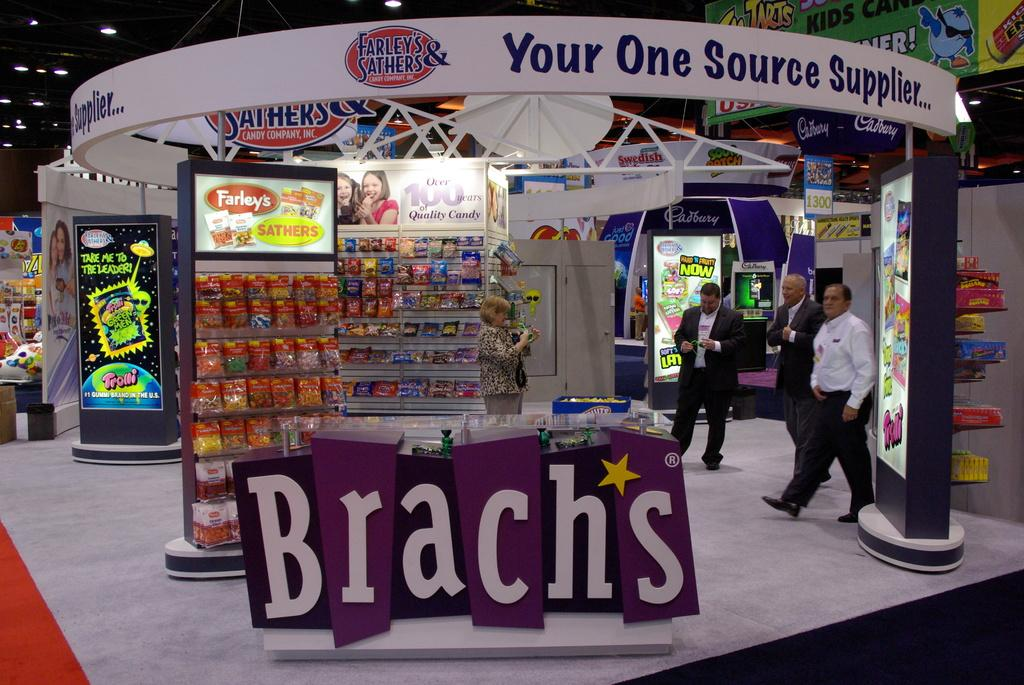<image>
Relay a brief, clear account of the picture shown. A kiosk of Brach's candy has many colorful displays. 